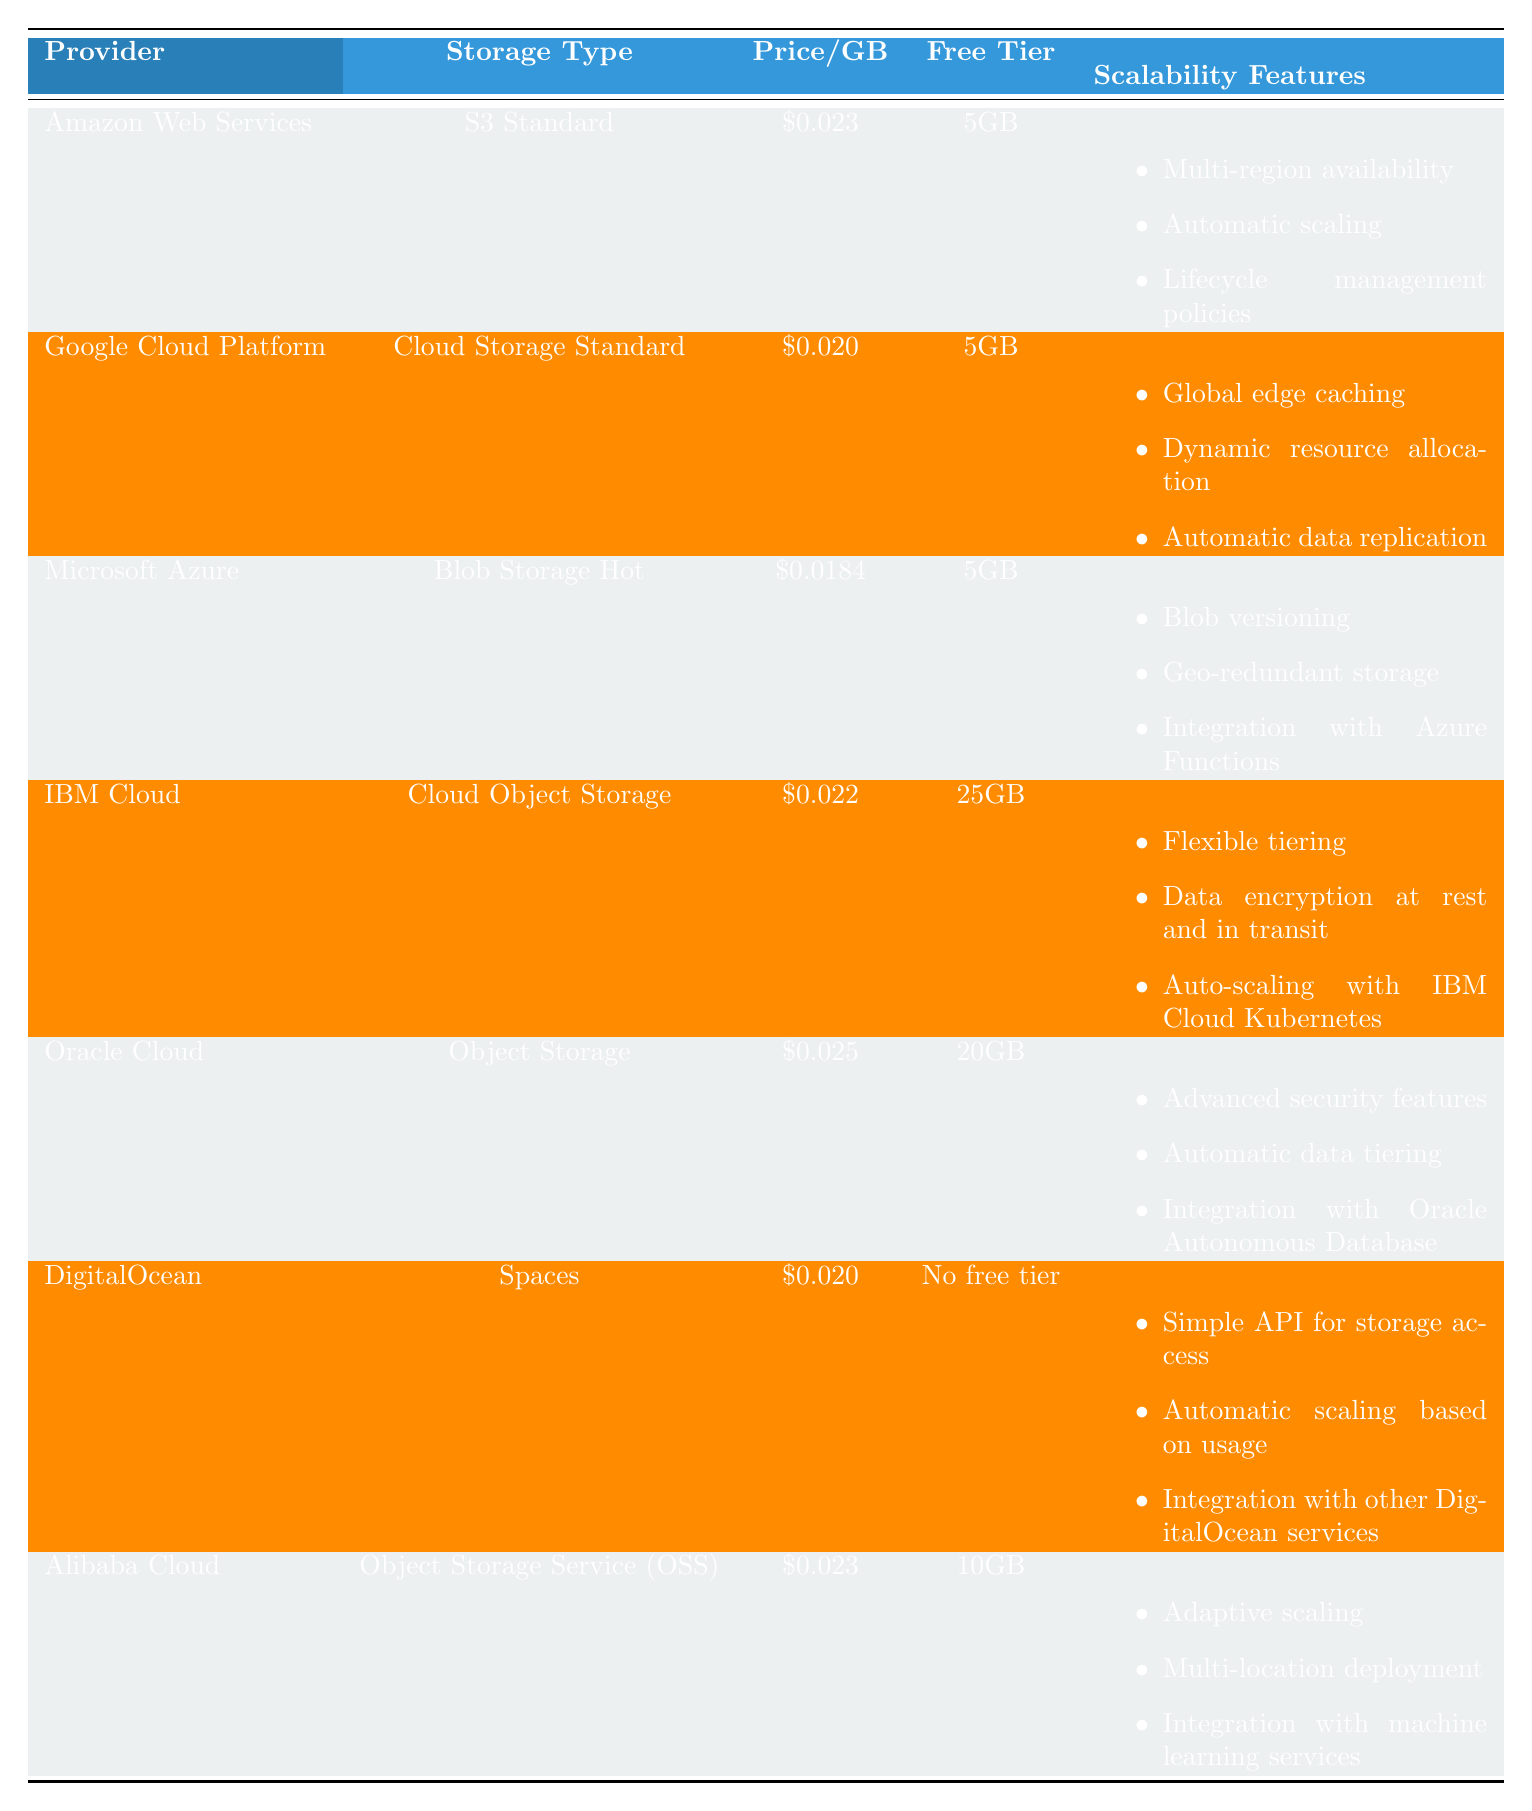What is the cheapest storage option among the providers? The table indicates that Microsoft's Azure Blob Storage Hot has the lowest price per GB at \$0.0184.
Answer: Azure Blob Storage Hot What is the free tier limit for IBM Cloud? According to the table, IBM Cloud offers a free tier limit of 25GB.
Answer: 25GB Which providers offer a free tier of 5GB? The providers offering a 5GB free tier are Amazon Web Services, Google Cloud Platform, and Microsoft Azure, as per the table.
Answer: Amazon Web Services, Google Cloud Platform, Microsoft Azure How much does it cost to store 100GB of data with Google Cloud Platform? The cost per GB for Google Cloud Platform is \$0.020. Therefore, for 100GB, the cost is 100 * \$0.020 = \$2.00.
Answer: \$2.00 Do Oracle Cloud's storage services have automatic data tiering? The table states that Oracle Cloud has automatic data tiering as one of its scalability features.
Answer: Yes What are the three scalability features offered by Amazon Web Services? The scalability features listed for Amazon Web Services are multi-region availability, automatic scaling, and lifecycle management policies as shown in the table.
Answer: Multi-region availability, automatic scaling, lifecycle management policies What is the difference in price per GB between Microsoft Azure and Oracle Cloud? Microsoft Azure's price is \$0.0184 and Oracle Cloud's price is \$0.025. The difference is \$0.025 - \$0.0184 = \$0.0066.
Answer: \$0.0066 Which provider has the highest free tier limit? The table shows IBM Cloud has the highest free tier limit at 25GB compared to others.
Answer: IBM Cloud Summarize the unique scalability features offered by DigitalOcean and Alibaba Cloud. DigitalOcean offers simple API for storage access, automatic scaling based on usage, and integration with other DigitalOcean services; while Alibaba Cloud offers adaptive scaling, multi-location deployment, and integration with machine learning services.
Answer: DigitalOcean: Simple API, automatic scaling, integration; Alibaba Cloud: Adaptive scaling, multi-location deployment, integration How many providers offer a free tier larger than 5GB? In the table, IBM Cloud and Oracle Cloud offer free tiers larger than 5GB. IBM offers 25GB and Oracle offers 20GB. Thus, there are 2 providers.
Answer: 2 